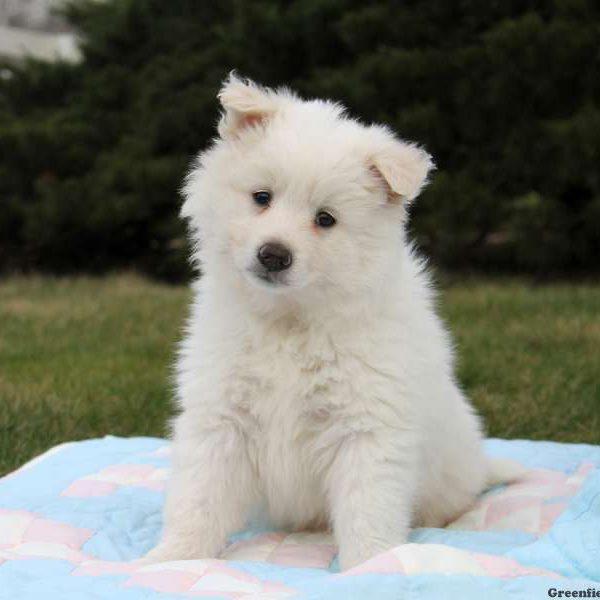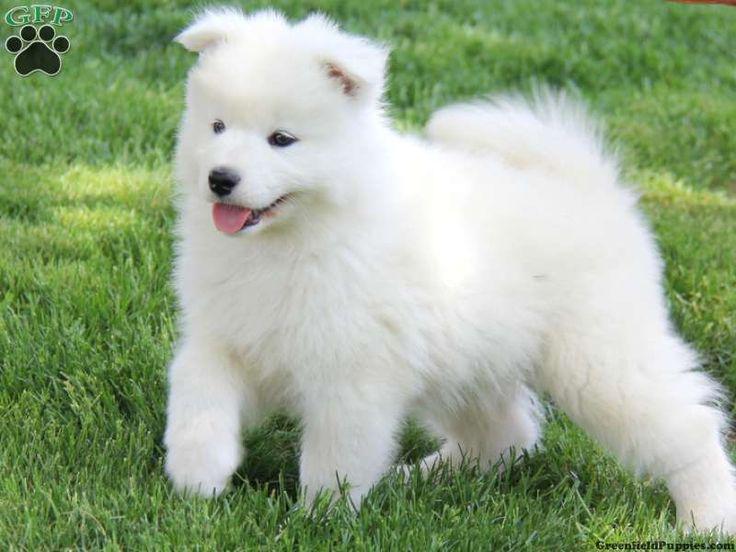The first image is the image on the left, the second image is the image on the right. Considering the images on both sides, is "Each image contains exactly one dog, and all dogs are white and posed outdoors." valid? Answer yes or no. Yes. The first image is the image on the left, the second image is the image on the right. For the images shown, is this caption "The dog in the image on the right is standing on the grass." true? Answer yes or no. Yes. 